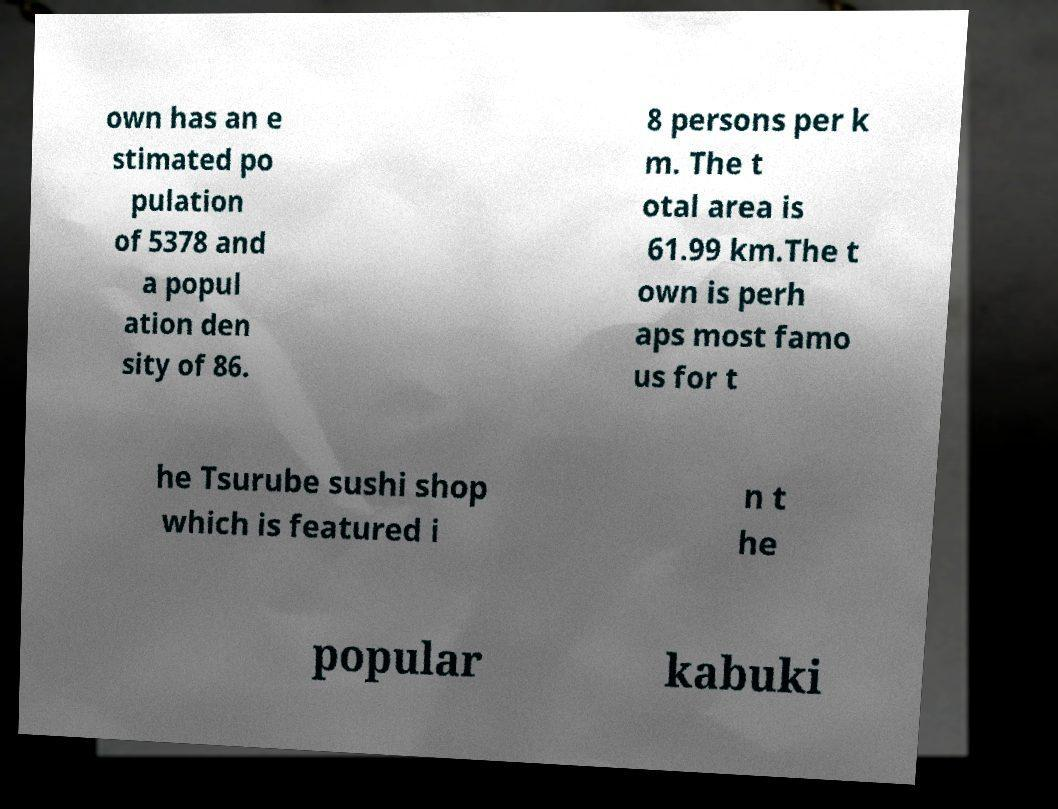Can you accurately transcribe the text from the provided image for me? own has an e stimated po pulation of 5378 and a popul ation den sity of 86. 8 persons per k m. The t otal area is 61.99 km.The t own is perh aps most famo us for t he Tsurube sushi shop which is featured i n t he popular kabuki 